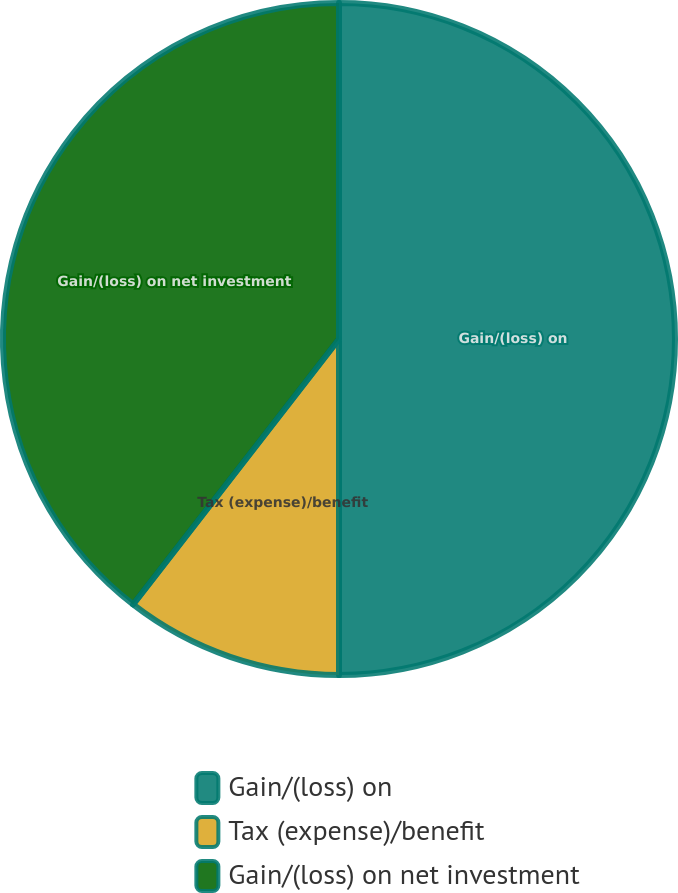<chart> <loc_0><loc_0><loc_500><loc_500><pie_chart><fcel>Gain/(loss) on<fcel>Tax (expense)/benefit<fcel>Gain/(loss) on net investment<nl><fcel>50.0%<fcel>10.5%<fcel>39.5%<nl></chart> 